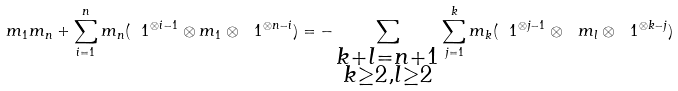Convert formula to latex. <formula><loc_0><loc_0><loc_500><loc_500>m _ { 1 } m _ { n } + \sum _ { i = 1 } ^ { n } m _ { n } ( \ 1 ^ { \otimes i - 1 } \otimes m _ { 1 } \otimes \ 1 ^ { \otimes n - i } ) = - \sum _ { \substack { k + l = n + 1 \\ k \geq 2 , l \geq 2 } } \sum _ { j = 1 } ^ { k } m _ { k } ( \ 1 ^ { \otimes j - 1 } \otimes \ m _ { l } \otimes \ 1 ^ { \otimes k - j } )</formula> 